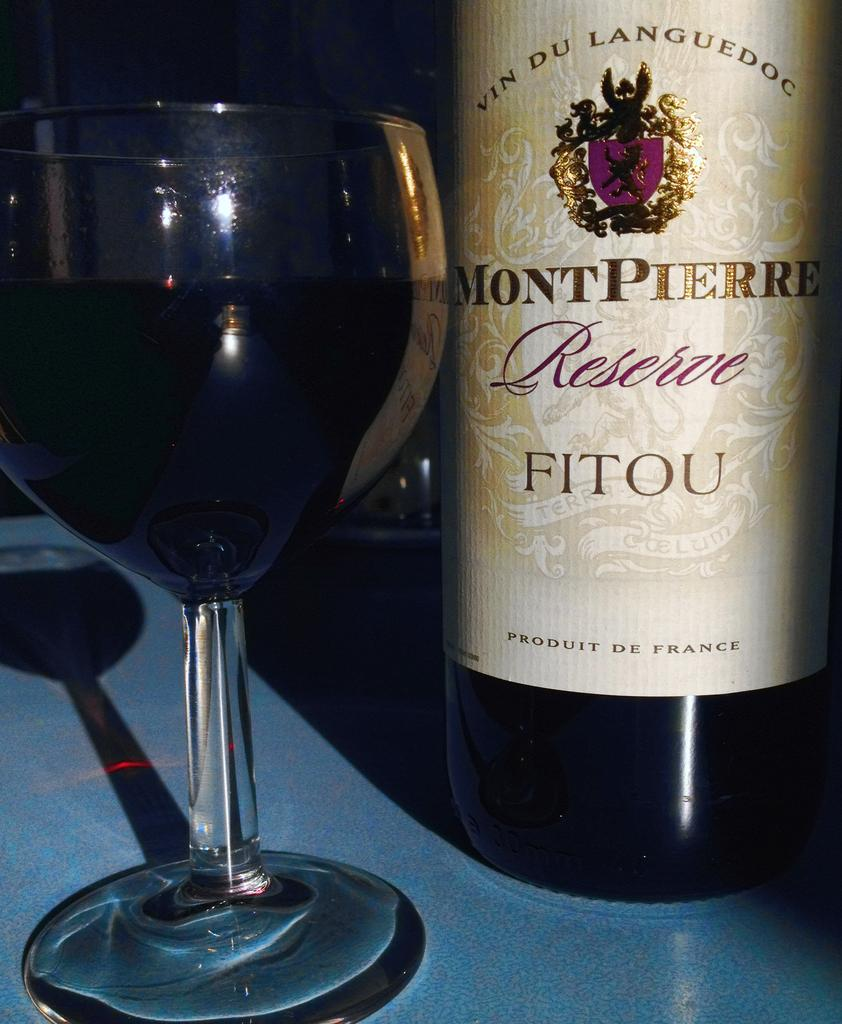What is present in the image that can hold a liquid? There is a bottle and a glass with a drink in the image. What can be observed on the glass in the image? The glass has a reflection on the table. Where are the bottle and glass located in the image? The bottle and glass are on a table. Can you tell me how many rabbits are sitting on the library shelves in the image? There are no rabbits or library shelves present in the image. 